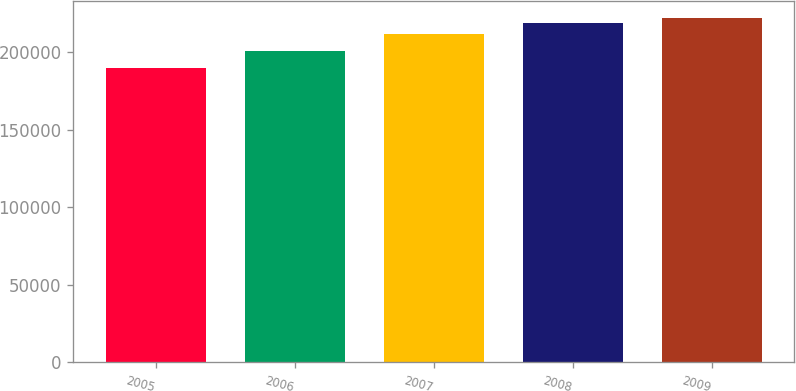<chart> <loc_0><loc_0><loc_500><loc_500><bar_chart><fcel>2005<fcel>2006<fcel>2007<fcel>2008<fcel>2009<nl><fcel>190000<fcel>201000<fcel>212000<fcel>219000<fcel>222200<nl></chart> 